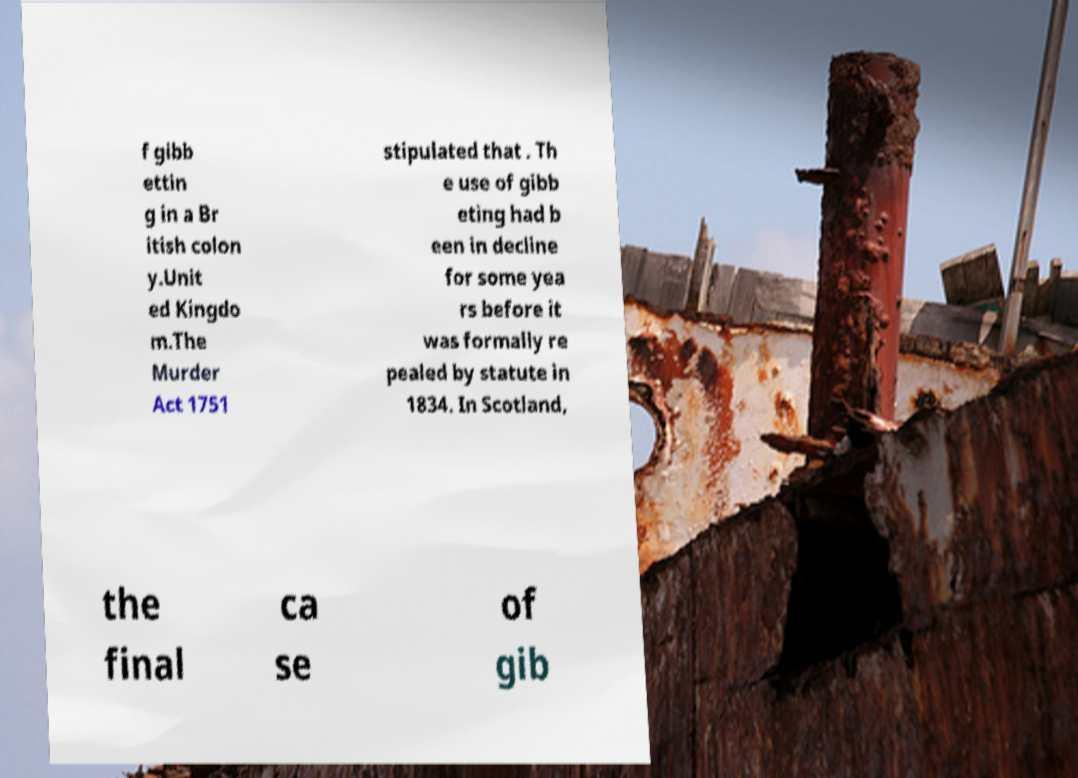Please read and relay the text visible in this image. What does it say? f gibb ettin g in a Br itish colon y.Unit ed Kingdo m.The Murder Act 1751 stipulated that . Th e use of gibb eting had b een in decline for some yea rs before it was formally re pealed by statute in 1834. In Scotland, the final ca se of gib 